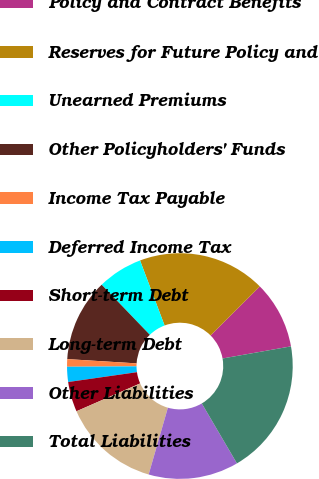Convert chart. <chart><loc_0><loc_0><loc_500><loc_500><pie_chart><fcel>Policy and Contract Benefits<fcel>Reserves for Future Policy and<fcel>Unearned Premiums<fcel>Other Policyholders' Funds<fcel>Income Tax Payable<fcel>Deferred Income Tax<fcel>Short-term Debt<fcel>Long-term Debt<fcel>Other Liabilities<fcel>Total Liabilities<nl><fcel>9.68%<fcel>18.27%<fcel>6.45%<fcel>11.83%<fcel>1.08%<fcel>2.16%<fcel>4.3%<fcel>13.98%<fcel>12.9%<fcel>19.35%<nl></chart> 